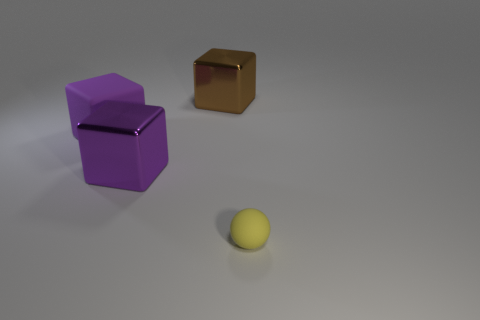Subtract all blocks. How many objects are left? 1 Add 3 shiny blocks. How many shiny blocks exist? 5 Add 1 brown matte balls. How many objects exist? 5 Subtract all brown cubes. How many cubes are left? 2 Subtract all large rubber blocks. How many blocks are left? 2 Subtract 0 yellow cubes. How many objects are left? 4 Subtract 1 spheres. How many spheres are left? 0 Subtract all brown balls. Subtract all red cylinders. How many balls are left? 1 Subtract all blue blocks. How many purple balls are left? 0 Subtract all purple rubber blocks. Subtract all rubber cubes. How many objects are left? 2 